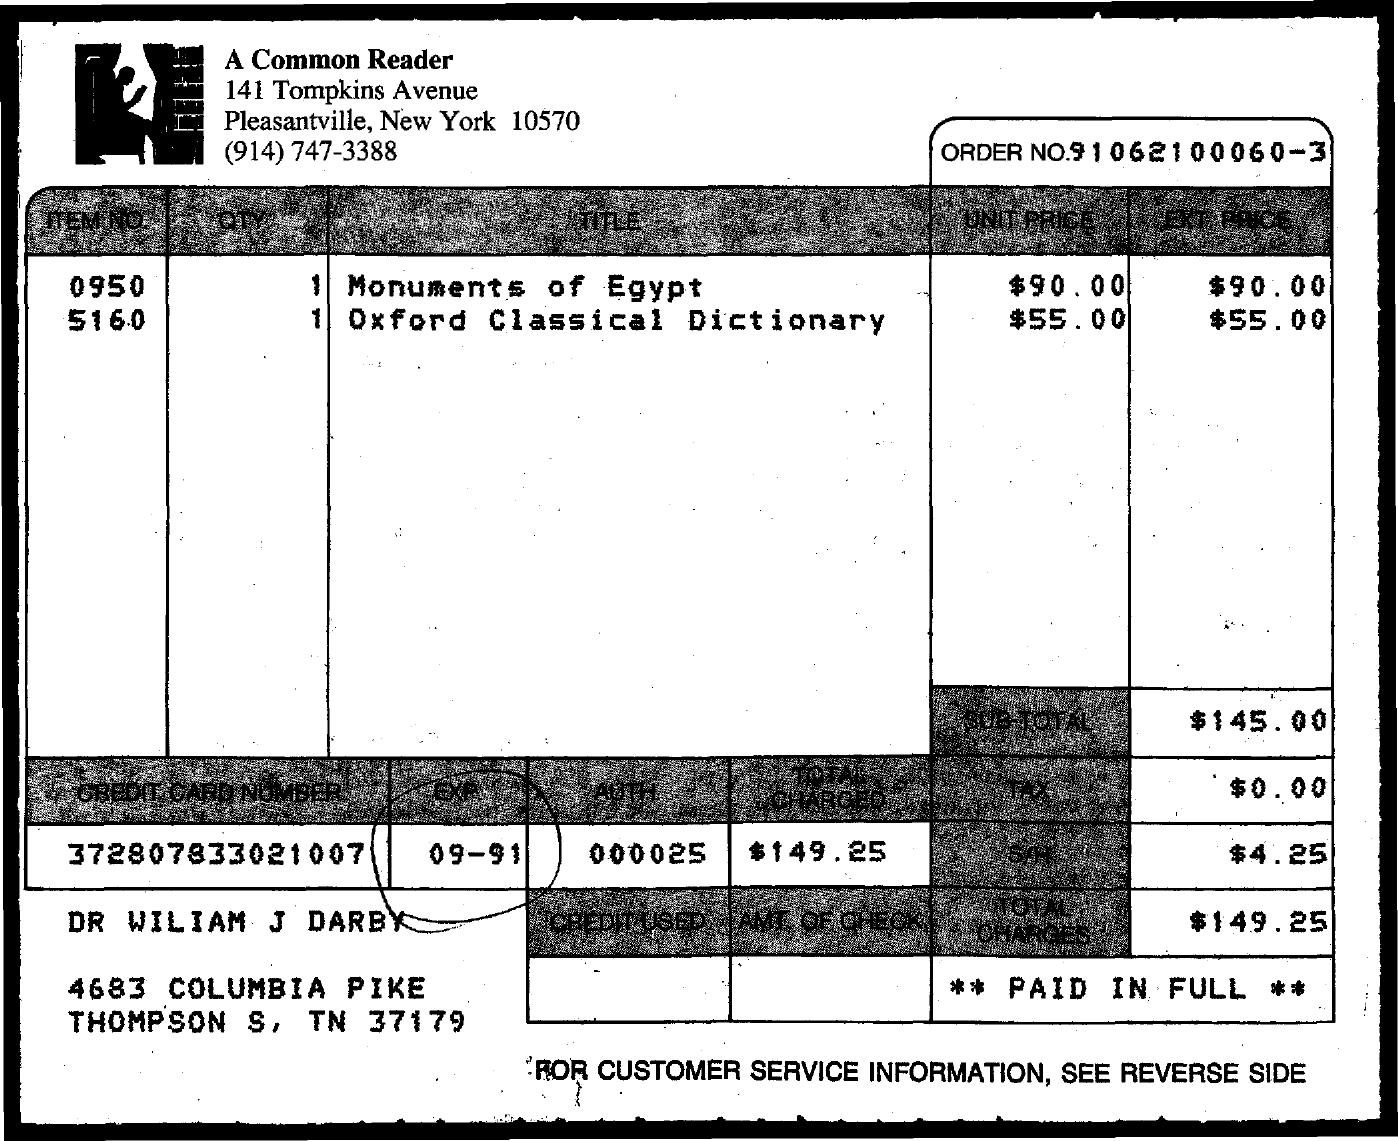What is the credit card number mentioned?
Provide a short and direct response. 372807833021007. What is the total charges?
Provide a short and direct response. $149.25. What is exp mentioned?
Your answer should be very brief. 09-91. 